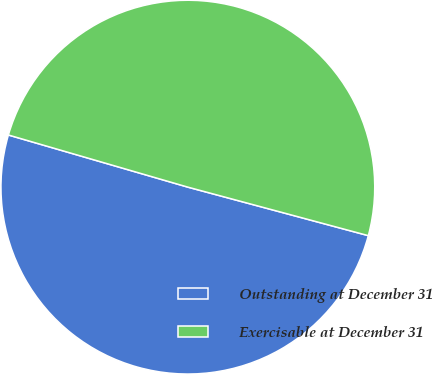Convert chart. <chart><loc_0><loc_0><loc_500><loc_500><pie_chart><fcel>Outstanding at December 31<fcel>Exercisable at December 31<nl><fcel>50.32%<fcel>49.68%<nl></chart> 